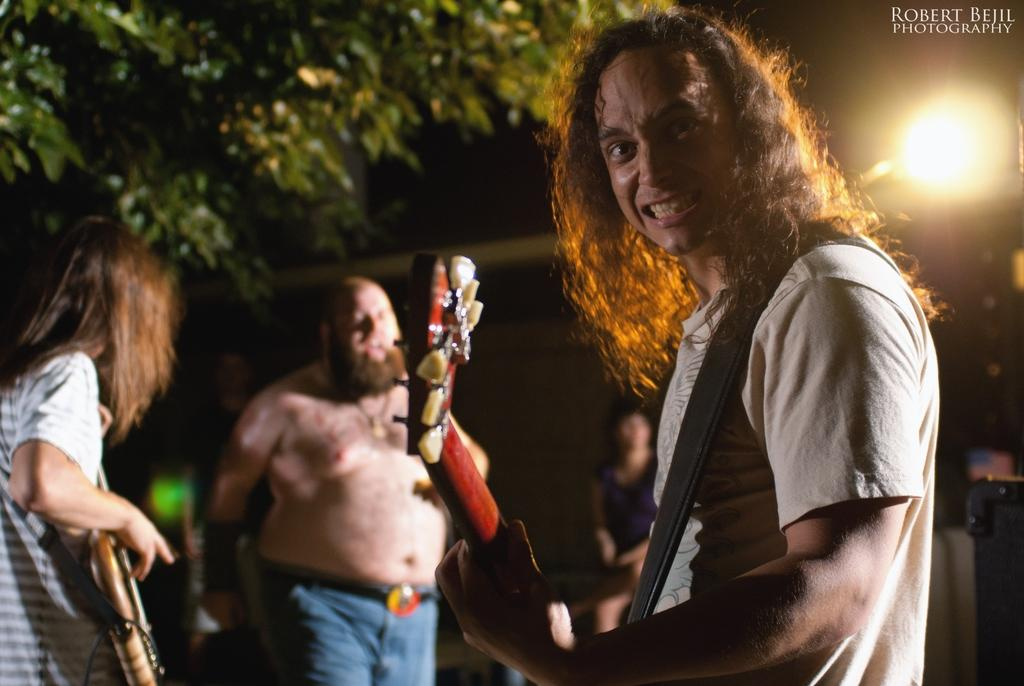How many people are in the image? There are persons in the image, but the exact number is not specified. What are some of the persons doing in the image? Some of the persons are holding musical instruments. What can be seen in the background of the image? There is a tree and lights in the background of the image. When was the image taken? The image was taken during nighttime. Can you see any carts or trucks in the image? There is no mention of carts or trucks in the image; the focus is on the persons holding musical instruments and the background elements. 